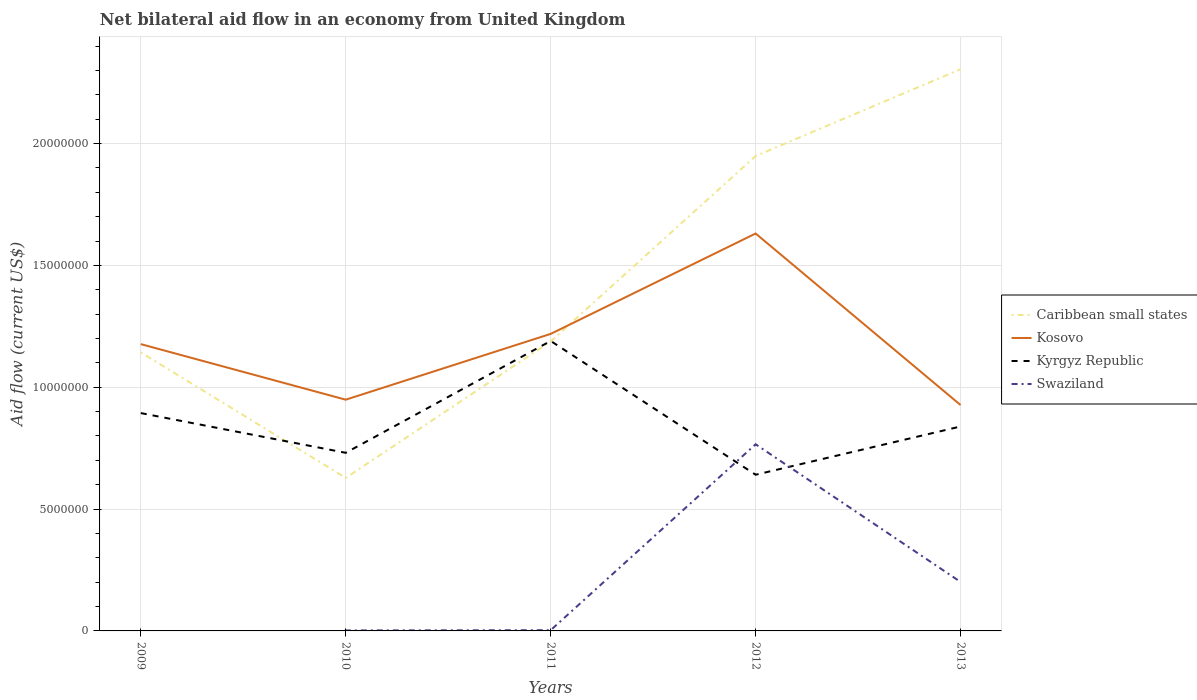Across all years, what is the maximum net bilateral aid flow in Caribbean small states?
Your response must be concise. 6.28e+06. What is the total net bilateral aid flow in Caribbean small states in the graph?
Keep it short and to the point. -4.50e+05. What is the difference between the highest and the second highest net bilateral aid flow in Kosovo?
Give a very brief answer. 7.04e+06. What is the difference between the highest and the lowest net bilateral aid flow in Kyrgyz Republic?
Ensure brevity in your answer.  2. How many years are there in the graph?
Provide a short and direct response. 5. What is the difference between two consecutive major ticks on the Y-axis?
Make the answer very short. 5.00e+06. How many legend labels are there?
Your response must be concise. 4. How are the legend labels stacked?
Provide a short and direct response. Vertical. What is the title of the graph?
Offer a terse response. Net bilateral aid flow in an economy from United Kingdom. What is the Aid flow (current US$) of Caribbean small states in 2009?
Make the answer very short. 1.14e+07. What is the Aid flow (current US$) in Kosovo in 2009?
Offer a terse response. 1.18e+07. What is the Aid flow (current US$) in Kyrgyz Republic in 2009?
Offer a terse response. 8.94e+06. What is the Aid flow (current US$) in Caribbean small states in 2010?
Provide a succinct answer. 6.28e+06. What is the Aid flow (current US$) in Kosovo in 2010?
Provide a short and direct response. 9.49e+06. What is the Aid flow (current US$) of Kyrgyz Republic in 2010?
Provide a short and direct response. 7.31e+06. What is the Aid flow (current US$) in Caribbean small states in 2011?
Your response must be concise. 1.19e+07. What is the Aid flow (current US$) of Kosovo in 2011?
Provide a succinct answer. 1.22e+07. What is the Aid flow (current US$) in Kyrgyz Republic in 2011?
Make the answer very short. 1.19e+07. What is the Aid flow (current US$) in Swaziland in 2011?
Make the answer very short. 3.00e+04. What is the Aid flow (current US$) in Caribbean small states in 2012?
Offer a very short reply. 1.95e+07. What is the Aid flow (current US$) in Kosovo in 2012?
Offer a very short reply. 1.63e+07. What is the Aid flow (current US$) in Kyrgyz Republic in 2012?
Offer a terse response. 6.41e+06. What is the Aid flow (current US$) of Swaziland in 2012?
Offer a terse response. 7.66e+06. What is the Aid flow (current US$) in Caribbean small states in 2013?
Provide a succinct answer. 2.30e+07. What is the Aid flow (current US$) in Kosovo in 2013?
Keep it short and to the point. 9.27e+06. What is the Aid flow (current US$) in Kyrgyz Republic in 2013?
Offer a terse response. 8.39e+06. What is the Aid flow (current US$) of Swaziland in 2013?
Your answer should be compact. 2.01e+06. Across all years, what is the maximum Aid flow (current US$) of Caribbean small states?
Ensure brevity in your answer.  2.30e+07. Across all years, what is the maximum Aid flow (current US$) in Kosovo?
Offer a very short reply. 1.63e+07. Across all years, what is the maximum Aid flow (current US$) in Kyrgyz Republic?
Keep it short and to the point. 1.19e+07. Across all years, what is the maximum Aid flow (current US$) in Swaziland?
Offer a terse response. 7.66e+06. Across all years, what is the minimum Aid flow (current US$) of Caribbean small states?
Ensure brevity in your answer.  6.28e+06. Across all years, what is the minimum Aid flow (current US$) of Kosovo?
Give a very brief answer. 9.27e+06. Across all years, what is the minimum Aid flow (current US$) of Kyrgyz Republic?
Ensure brevity in your answer.  6.41e+06. Across all years, what is the minimum Aid flow (current US$) in Swaziland?
Offer a terse response. 0. What is the total Aid flow (current US$) in Caribbean small states in the graph?
Your answer should be compact. 7.21e+07. What is the total Aid flow (current US$) of Kosovo in the graph?
Keep it short and to the point. 5.90e+07. What is the total Aid flow (current US$) of Kyrgyz Republic in the graph?
Provide a short and direct response. 4.30e+07. What is the total Aid flow (current US$) of Swaziland in the graph?
Ensure brevity in your answer.  9.72e+06. What is the difference between the Aid flow (current US$) of Caribbean small states in 2009 and that in 2010?
Offer a very short reply. 5.15e+06. What is the difference between the Aid flow (current US$) of Kosovo in 2009 and that in 2010?
Your answer should be compact. 2.28e+06. What is the difference between the Aid flow (current US$) of Kyrgyz Republic in 2009 and that in 2010?
Make the answer very short. 1.63e+06. What is the difference between the Aid flow (current US$) in Caribbean small states in 2009 and that in 2011?
Provide a succinct answer. -4.50e+05. What is the difference between the Aid flow (current US$) of Kosovo in 2009 and that in 2011?
Offer a very short reply. -4.20e+05. What is the difference between the Aid flow (current US$) of Kyrgyz Republic in 2009 and that in 2011?
Your answer should be compact. -2.96e+06. What is the difference between the Aid flow (current US$) of Caribbean small states in 2009 and that in 2012?
Ensure brevity in your answer.  -8.06e+06. What is the difference between the Aid flow (current US$) of Kosovo in 2009 and that in 2012?
Offer a terse response. -4.54e+06. What is the difference between the Aid flow (current US$) of Kyrgyz Republic in 2009 and that in 2012?
Your answer should be compact. 2.53e+06. What is the difference between the Aid flow (current US$) in Caribbean small states in 2009 and that in 2013?
Ensure brevity in your answer.  -1.16e+07. What is the difference between the Aid flow (current US$) of Kosovo in 2009 and that in 2013?
Make the answer very short. 2.50e+06. What is the difference between the Aid flow (current US$) of Caribbean small states in 2010 and that in 2011?
Offer a terse response. -5.60e+06. What is the difference between the Aid flow (current US$) of Kosovo in 2010 and that in 2011?
Your response must be concise. -2.70e+06. What is the difference between the Aid flow (current US$) in Kyrgyz Republic in 2010 and that in 2011?
Ensure brevity in your answer.  -4.59e+06. What is the difference between the Aid flow (current US$) of Swaziland in 2010 and that in 2011?
Make the answer very short. -10000. What is the difference between the Aid flow (current US$) in Caribbean small states in 2010 and that in 2012?
Keep it short and to the point. -1.32e+07. What is the difference between the Aid flow (current US$) of Kosovo in 2010 and that in 2012?
Make the answer very short. -6.82e+06. What is the difference between the Aid flow (current US$) in Kyrgyz Republic in 2010 and that in 2012?
Your answer should be very brief. 9.00e+05. What is the difference between the Aid flow (current US$) of Swaziland in 2010 and that in 2012?
Provide a succinct answer. -7.64e+06. What is the difference between the Aid flow (current US$) in Caribbean small states in 2010 and that in 2013?
Ensure brevity in your answer.  -1.68e+07. What is the difference between the Aid flow (current US$) in Kyrgyz Republic in 2010 and that in 2013?
Your answer should be very brief. -1.08e+06. What is the difference between the Aid flow (current US$) in Swaziland in 2010 and that in 2013?
Your answer should be very brief. -1.99e+06. What is the difference between the Aid flow (current US$) in Caribbean small states in 2011 and that in 2012?
Your answer should be compact. -7.61e+06. What is the difference between the Aid flow (current US$) of Kosovo in 2011 and that in 2012?
Your answer should be very brief. -4.12e+06. What is the difference between the Aid flow (current US$) in Kyrgyz Republic in 2011 and that in 2012?
Ensure brevity in your answer.  5.49e+06. What is the difference between the Aid flow (current US$) in Swaziland in 2011 and that in 2012?
Offer a very short reply. -7.63e+06. What is the difference between the Aid flow (current US$) in Caribbean small states in 2011 and that in 2013?
Your response must be concise. -1.12e+07. What is the difference between the Aid flow (current US$) in Kosovo in 2011 and that in 2013?
Provide a short and direct response. 2.92e+06. What is the difference between the Aid flow (current US$) in Kyrgyz Republic in 2011 and that in 2013?
Your response must be concise. 3.51e+06. What is the difference between the Aid flow (current US$) in Swaziland in 2011 and that in 2013?
Your response must be concise. -1.98e+06. What is the difference between the Aid flow (current US$) in Caribbean small states in 2012 and that in 2013?
Give a very brief answer. -3.56e+06. What is the difference between the Aid flow (current US$) of Kosovo in 2012 and that in 2013?
Make the answer very short. 7.04e+06. What is the difference between the Aid flow (current US$) in Kyrgyz Republic in 2012 and that in 2013?
Offer a terse response. -1.98e+06. What is the difference between the Aid flow (current US$) in Swaziland in 2012 and that in 2013?
Give a very brief answer. 5.65e+06. What is the difference between the Aid flow (current US$) in Caribbean small states in 2009 and the Aid flow (current US$) in Kosovo in 2010?
Offer a very short reply. 1.94e+06. What is the difference between the Aid flow (current US$) in Caribbean small states in 2009 and the Aid flow (current US$) in Kyrgyz Republic in 2010?
Provide a succinct answer. 4.12e+06. What is the difference between the Aid flow (current US$) of Caribbean small states in 2009 and the Aid flow (current US$) of Swaziland in 2010?
Offer a terse response. 1.14e+07. What is the difference between the Aid flow (current US$) in Kosovo in 2009 and the Aid flow (current US$) in Kyrgyz Republic in 2010?
Offer a very short reply. 4.46e+06. What is the difference between the Aid flow (current US$) in Kosovo in 2009 and the Aid flow (current US$) in Swaziland in 2010?
Offer a terse response. 1.18e+07. What is the difference between the Aid flow (current US$) of Kyrgyz Republic in 2009 and the Aid flow (current US$) of Swaziland in 2010?
Keep it short and to the point. 8.92e+06. What is the difference between the Aid flow (current US$) in Caribbean small states in 2009 and the Aid flow (current US$) in Kosovo in 2011?
Offer a terse response. -7.60e+05. What is the difference between the Aid flow (current US$) of Caribbean small states in 2009 and the Aid flow (current US$) of Kyrgyz Republic in 2011?
Provide a short and direct response. -4.70e+05. What is the difference between the Aid flow (current US$) of Caribbean small states in 2009 and the Aid flow (current US$) of Swaziland in 2011?
Your answer should be compact. 1.14e+07. What is the difference between the Aid flow (current US$) of Kosovo in 2009 and the Aid flow (current US$) of Swaziland in 2011?
Provide a succinct answer. 1.17e+07. What is the difference between the Aid flow (current US$) of Kyrgyz Republic in 2009 and the Aid flow (current US$) of Swaziland in 2011?
Your response must be concise. 8.91e+06. What is the difference between the Aid flow (current US$) in Caribbean small states in 2009 and the Aid flow (current US$) in Kosovo in 2012?
Provide a succinct answer. -4.88e+06. What is the difference between the Aid flow (current US$) of Caribbean small states in 2009 and the Aid flow (current US$) of Kyrgyz Republic in 2012?
Provide a succinct answer. 5.02e+06. What is the difference between the Aid flow (current US$) of Caribbean small states in 2009 and the Aid flow (current US$) of Swaziland in 2012?
Make the answer very short. 3.77e+06. What is the difference between the Aid flow (current US$) in Kosovo in 2009 and the Aid flow (current US$) in Kyrgyz Republic in 2012?
Your answer should be compact. 5.36e+06. What is the difference between the Aid flow (current US$) in Kosovo in 2009 and the Aid flow (current US$) in Swaziland in 2012?
Offer a terse response. 4.11e+06. What is the difference between the Aid flow (current US$) of Kyrgyz Republic in 2009 and the Aid flow (current US$) of Swaziland in 2012?
Give a very brief answer. 1.28e+06. What is the difference between the Aid flow (current US$) in Caribbean small states in 2009 and the Aid flow (current US$) in Kosovo in 2013?
Your answer should be very brief. 2.16e+06. What is the difference between the Aid flow (current US$) of Caribbean small states in 2009 and the Aid flow (current US$) of Kyrgyz Republic in 2013?
Provide a succinct answer. 3.04e+06. What is the difference between the Aid flow (current US$) of Caribbean small states in 2009 and the Aid flow (current US$) of Swaziland in 2013?
Keep it short and to the point. 9.42e+06. What is the difference between the Aid flow (current US$) of Kosovo in 2009 and the Aid flow (current US$) of Kyrgyz Republic in 2013?
Ensure brevity in your answer.  3.38e+06. What is the difference between the Aid flow (current US$) of Kosovo in 2009 and the Aid flow (current US$) of Swaziland in 2013?
Provide a succinct answer. 9.76e+06. What is the difference between the Aid flow (current US$) of Kyrgyz Republic in 2009 and the Aid flow (current US$) of Swaziland in 2013?
Keep it short and to the point. 6.93e+06. What is the difference between the Aid flow (current US$) in Caribbean small states in 2010 and the Aid flow (current US$) in Kosovo in 2011?
Keep it short and to the point. -5.91e+06. What is the difference between the Aid flow (current US$) of Caribbean small states in 2010 and the Aid flow (current US$) of Kyrgyz Republic in 2011?
Make the answer very short. -5.62e+06. What is the difference between the Aid flow (current US$) in Caribbean small states in 2010 and the Aid flow (current US$) in Swaziland in 2011?
Your answer should be very brief. 6.25e+06. What is the difference between the Aid flow (current US$) in Kosovo in 2010 and the Aid flow (current US$) in Kyrgyz Republic in 2011?
Your response must be concise. -2.41e+06. What is the difference between the Aid flow (current US$) of Kosovo in 2010 and the Aid flow (current US$) of Swaziland in 2011?
Your answer should be compact. 9.46e+06. What is the difference between the Aid flow (current US$) of Kyrgyz Republic in 2010 and the Aid flow (current US$) of Swaziland in 2011?
Make the answer very short. 7.28e+06. What is the difference between the Aid flow (current US$) of Caribbean small states in 2010 and the Aid flow (current US$) of Kosovo in 2012?
Ensure brevity in your answer.  -1.00e+07. What is the difference between the Aid flow (current US$) in Caribbean small states in 2010 and the Aid flow (current US$) in Swaziland in 2012?
Offer a terse response. -1.38e+06. What is the difference between the Aid flow (current US$) in Kosovo in 2010 and the Aid flow (current US$) in Kyrgyz Republic in 2012?
Make the answer very short. 3.08e+06. What is the difference between the Aid flow (current US$) of Kosovo in 2010 and the Aid flow (current US$) of Swaziland in 2012?
Make the answer very short. 1.83e+06. What is the difference between the Aid flow (current US$) of Kyrgyz Republic in 2010 and the Aid flow (current US$) of Swaziland in 2012?
Give a very brief answer. -3.50e+05. What is the difference between the Aid flow (current US$) of Caribbean small states in 2010 and the Aid flow (current US$) of Kosovo in 2013?
Offer a terse response. -2.99e+06. What is the difference between the Aid flow (current US$) in Caribbean small states in 2010 and the Aid flow (current US$) in Kyrgyz Republic in 2013?
Your answer should be very brief. -2.11e+06. What is the difference between the Aid flow (current US$) in Caribbean small states in 2010 and the Aid flow (current US$) in Swaziland in 2013?
Provide a short and direct response. 4.27e+06. What is the difference between the Aid flow (current US$) of Kosovo in 2010 and the Aid flow (current US$) of Kyrgyz Republic in 2013?
Your response must be concise. 1.10e+06. What is the difference between the Aid flow (current US$) in Kosovo in 2010 and the Aid flow (current US$) in Swaziland in 2013?
Your response must be concise. 7.48e+06. What is the difference between the Aid flow (current US$) in Kyrgyz Republic in 2010 and the Aid flow (current US$) in Swaziland in 2013?
Keep it short and to the point. 5.30e+06. What is the difference between the Aid flow (current US$) in Caribbean small states in 2011 and the Aid flow (current US$) in Kosovo in 2012?
Offer a very short reply. -4.43e+06. What is the difference between the Aid flow (current US$) in Caribbean small states in 2011 and the Aid flow (current US$) in Kyrgyz Republic in 2012?
Your answer should be compact. 5.47e+06. What is the difference between the Aid flow (current US$) in Caribbean small states in 2011 and the Aid flow (current US$) in Swaziland in 2012?
Your response must be concise. 4.22e+06. What is the difference between the Aid flow (current US$) of Kosovo in 2011 and the Aid flow (current US$) of Kyrgyz Republic in 2012?
Your answer should be compact. 5.78e+06. What is the difference between the Aid flow (current US$) in Kosovo in 2011 and the Aid flow (current US$) in Swaziland in 2012?
Your answer should be compact. 4.53e+06. What is the difference between the Aid flow (current US$) in Kyrgyz Republic in 2011 and the Aid flow (current US$) in Swaziland in 2012?
Your answer should be compact. 4.24e+06. What is the difference between the Aid flow (current US$) of Caribbean small states in 2011 and the Aid flow (current US$) of Kosovo in 2013?
Your answer should be compact. 2.61e+06. What is the difference between the Aid flow (current US$) of Caribbean small states in 2011 and the Aid flow (current US$) of Kyrgyz Republic in 2013?
Give a very brief answer. 3.49e+06. What is the difference between the Aid flow (current US$) of Caribbean small states in 2011 and the Aid flow (current US$) of Swaziland in 2013?
Your answer should be very brief. 9.87e+06. What is the difference between the Aid flow (current US$) of Kosovo in 2011 and the Aid flow (current US$) of Kyrgyz Republic in 2013?
Offer a very short reply. 3.80e+06. What is the difference between the Aid flow (current US$) in Kosovo in 2011 and the Aid flow (current US$) in Swaziland in 2013?
Provide a short and direct response. 1.02e+07. What is the difference between the Aid flow (current US$) in Kyrgyz Republic in 2011 and the Aid flow (current US$) in Swaziland in 2013?
Offer a terse response. 9.89e+06. What is the difference between the Aid flow (current US$) of Caribbean small states in 2012 and the Aid flow (current US$) of Kosovo in 2013?
Your answer should be compact. 1.02e+07. What is the difference between the Aid flow (current US$) in Caribbean small states in 2012 and the Aid flow (current US$) in Kyrgyz Republic in 2013?
Provide a short and direct response. 1.11e+07. What is the difference between the Aid flow (current US$) in Caribbean small states in 2012 and the Aid flow (current US$) in Swaziland in 2013?
Keep it short and to the point. 1.75e+07. What is the difference between the Aid flow (current US$) of Kosovo in 2012 and the Aid flow (current US$) of Kyrgyz Republic in 2013?
Your response must be concise. 7.92e+06. What is the difference between the Aid flow (current US$) in Kosovo in 2012 and the Aid flow (current US$) in Swaziland in 2013?
Ensure brevity in your answer.  1.43e+07. What is the difference between the Aid flow (current US$) of Kyrgyz Republic in 2012 and the Aid flow (current US$) of Swaziland in 2013?
Offer a terse response. 4.40e+06. What is the average Aid flow (current US$) in Caribbean small states per year?
Keep it short and to the point. 1.44e+07. What is the average Aid flow (current US$) of Kosovo per year?
Provide a succinct answer. 1.18e+07. What is the average Aid flow (current US$) in Kyrgyz Republic per year?
Give a very brief answer. 8.59e+06. What is the average Aid flow (current US$) of Swaziland per year?
Offer a very short reply. 1.94e+06. In the year 2009, what is the difference between the Aid flow (current US$) in Caribbean small states and Aid flow (current US$) in Kosovo?
Make the answer very short. -3.40e+05. In the year 2009, what is the difference between the Aid flow (current US$) of Caribbean small states and Aid flow (current US$) of Kyrgyz Republic?
Your response must be concise. 2.49e+06. In the year 2009, what is the difference between the Aid flow (current US$) in Kosovo and Aid flow (current US$) in Kyrgyz Republic?
Your answer should be very brief. 2.83e+06. In the year 2010, what is the difference between the Aid flow (current US$) of Caribbean small states and Aid flow (current US$) of Kosovo?
Your response must be concise. -3.21e+06. In the year 2010, what is the difference between the Aid flow (current US$) in Caribbean small states and Aid flow (current US$) in Kyrgyz Republic?
Make the answer very short. -1.03e+06. In the year 2010, what is the difference between the Aid flow (current US$) in Caribbean small states and Aid flow (current US$) in Swaziland?
Keep it short and to the point. 6.26e+06. In the year 2010, what is the difference between the Aid flow (current US$) of Kosovo and Aid flow (current US$) of Kyrgyz Republic?
Give a very brief answer. 2.18e+06. In the year 2010, what is the difference between the Aid flow (current US$) of Kosovo and Aid flow (current US$) of Swaziland?
Your answer should be compact. 9.47e+06. In the year 2010, what is the difference between the Aid flow (current US$) in Kyrgyz Republic and Aid flow (current US$) in Swaziland?
Provide a succinct answer. 7.29e+06. In the year 2011, what is the difference between the Aid flow (current US$) in Caribbean small states and Aid flow (current US$) in Kosovo?
Offer a terse response. -3.10e+05. In the year 2011, what is the difference between the Aid flow (current US$) of Caribbean small states and Aid flow (current US$) of Kyrgyz Republic?
Offer a terse response. -2.00e+04. In the year 2011, what is the difference between the Aid flow (current US$) in Caribbean small states and Aid flow (current US$) in Swaziland?
Provide a short and direct response. 1.18e+07. In the year 2011, what is the difference between the Aid flow (current US$) in Kosovo and Aid flow (current US$) in Kyrgyz Republic?
Ensure brevity in your answer.  2.90e+05. In the year 2011, what is the difference between the Aid flow (current US$) of Kosovo and Aid flow (current US$) of Swaziland?
Your answer should be very brief. 1.22e+07. In the year 2011, what is the difference between the Aid flow (current US$) in Kyrgyz Republic and Aid flow (current US$) in Swaziland?
Keep it short and to the point. 1.19e+07. In the year 2012, what is the difference between the Aid flow (current US$) of Caribbean small states and Aid flow (current US$) of Kosovo?
Give a very brief answer. 3.18e+06. In the year 2012, what is the difference between the Aid flow (current US$) of Caribbean small states and Aid flow (current US$) of Kyrgyz Republic?
Offer a very short reply. 1.31e+07. In the year 2012, what is the difference between the Aid flow (current US$) of Caribbean small states and Aid flow (current US$) of Swaziland?
Give a very brief answer. 1.18e+07. In the year 2012, what is the difference between the Aid flow (current US$) of Kosovo and Aid flow (current US$) of Kyrgyz Republic?
Provide a short and direct response. 9.90e+06. In the year 2012, what is the difference between the Aid flow (current US$) of Kosovo and Aid flow (current US$) of Swaziland?
Your answer should be very brief. 8.65e+06. In the year 2012, what is the difference between the Aid flow (current US$) in Kyrgyz Republic and Aid flow (current US$) in Swaziland?
Your answer should be compact. -1.25e+06. In the year 2013, what is the difference between the Aid flow (current US$) in Caribbean small states and Aid flow (current US$) in Kosovo?
Provide a succinct answer. 1.38e+07. In the year 2013, what is the difference between the Aid flow (current US$) of Caribbean small states and Aid flow (current US$) of Kyrgyz Republic?
Your answer should be compact. 1.47e+07. In the year 2013, what is the difference between the Aid flow (current US$) of Caribbean small states and Aid flow (current US$) of Swaziland?
Provide a short and direct response. 2.10e+07. In the year 2013, what is the difference between the Aid flow (current US$) of Kosovo and Aid flow (current US$) of Kyrgyz Republic?
Provide a succinct answer. 8.80e+05. In the year 2013, what is the difference between the Aid flow (current US$) of Kosovo and Aid flow (current US$) of Swaziland?
Offer a very short reply. 7.26e+06. In the year 2013, what is the difference between the Aid flow (current US$) of Kyrgyz Republic and Aid flow (current US$) of Swaziland?
Offer a terse response. 6.38e+06. What is the ratio of the Aid flow (current US$) of Caribbean small states in 2009 to that in 2010?
Ensure brevity in your answer.  1.82. What is the ratio of the Aid flow (current US$) of Kosovo in 2009 to that in 2010?
Offer a terse response. 1.24. What is the ratio of the Aid flow (current US$) of Kyrgyz Republic in 2009 to that in 2010?
Give a very brief answer. 1.22. What is the ratio of the Aid flow (current US$) in Caribbean small states in 2009 to that in 2011?
Your response must be concise. 0.96. What is the ratio of the Aid flow (current US$) in Kosovo in 2009 to that in 2011?
Make the answer very short. 0.97. What is the ratio of the Aid flow (current US$) of Kyrgyz Republic in 2009 to that in 2011?
Make the answer very short. 0.75. What is the ratio of the Aid flow (current US$) of Caribbean small states in 2009 to that in 2012?
Your answer should be very brief. 0.59. What is the ratio of the Aid flow (current US$) of Kosovo in 2009 to that in 2012?
Provide a succinct answer. 0.72. What is the ratio of the Aid flow (current US$) of Kyrgyz Republic in 2009 to that in 2012?
Give a very brief answer. 1.39. What is the ratio of the Aid flow (current US$) in Caribbean small states in 2009 to that in 2013?
Your response must be concise. 0.5. What is the ratio of the Aid flow (current US$) of Kosovo in 2009 to that in 2013?
Offer a very short reply. 1.27. What is the ratio of the Aid flow (current US$) in Kyrgyz Republic in 2009 to that in 2013?
Your answer should be compact. 1.07. What is the ratio of the Aid flow (current US$) in Caribbean small states in 2010 to that in 2011?
Your answer should be compact. 0.53. What is the ratio of the Aid flow (current US$) of Kosovo in 2010 to that in 2011?
Provide a short and direct response. 0.78. What is the ratio of the Aid flow (current US$) of Kyrgyz Republic in 2010 to that in 2011?
Your answer should be compact. 0.61. What is the ratio of the Aid flow (current US$) of Swaziland in 2010 to that in 2011?
Make the answer very short. 0.67. What is the ratio of the Aid flow (current US$) of Caribbean small states in 2010 to that in 2012?
Your response must be concise. 0.32. What is the ratio of the Aid flow (current US$) in Kosovo in 2010 to that in 2012?
Your answer should be very brief. 0.58. What is the ratio of the Aid flow (current US$) of Kyrgyz Republic in 2010 to that in 2012?
Ensure brevity in your answer.  1.14. What is the ratio of the Aid flow (current US$) in Swaziland in 2010 to that in 2012?
Ensure brevity in your answer.  0. What is the ratio of the Aid flow (current US$) of Caribbean small states in 2010 to that in 2013?
Keep it short and to the point. 0.27. What is the ratio of the Aid flow (current US$) of Kosovo in 2010 to that in 2013?
Give a very brief answer. 1.02. What is the ratio of the Aid flow (current US$) of Kyrgyz Republic in 2010 to that in 2013?
Your answer should be very brief. 0.87. What is the ratio of the Aid flow (current US$) of Caribbean small states in 2011 to that in 2012?
Give a very brief answer. 0.61. What is the ratio of the Aid flow (current US$) in Kosovo in 2011 to that in 2012?
Make the answer very short. 0.75. What is the ratio of the Aid flow (current US$) of Kyrgyz Republic in 2011 to that in 2012?
Your response must be concise. 1.86. What is the ratio of the Aid flow (current US$) of Swaziland in 2011 to that in 2012?
Your response must be concise. 0. What is the ratio of the Aid flow (current US$) of Caribbean small states in 2011 to that in 2013?
Offer a very short reply. 0.52. What is the ratio of the Aid flow (current US$) in Kosovo in 2011 to that in 2013?
Your response must be concise. 1.31. What is the ratio of the Aid flow (current US$) in Kyrgyz Republic in 2011 to that in 2013?
Your answer should be compact. 1.42. What is the ratio of the Aid flow (current US$) of Swaziland in 2011 to that in 2013?
Make the answer very short. 0.01. What is the ratio of the Aid flow (current US$) of Caribbean small states in 2012 to that in 2013?
Your answer should be compact. 0.85. What is the ratio of the Aid flow (current US$) of Kosovo in 2012 to that in 2013?
Offer a very short reply. 1.76. What is the ratio of the Aid flow (current US$) of Kyrgyz Republic in 2012 to that in 2013?
Your answer should be very brief. 0.76. What is the ratio of the Aid flow (current US$) in Swaziland in 2012 to that in 2013?
Provide a succinct answer. 3.81. What is the difference between the highest and the second highest Aid flow (current US$) in Caribbean small states?
Give a very brief answer. 3.56e+06. What is the difference between the highest and the second highest Aid flow (current US$) of Kosovo?
Your answer should be compact. 4.12e+06. What is the difference between the highest and the second highest Aid flow (current US$) in Kyrgyz Republic?
Make the answer very short. 2.96e+06. What is the difference between the highest and the second highest Aid flow (current US$) of Swaziland?
Provide a short and direct response. 5.65e+06. What is the difference between the highest and the lowest Aid flow (current US$) of Caribbean small states?
Your answer should be compact. 1.68e+07. What is the difference between the highest and the lowest Aid flow (current US$) of Kosovo?
Your response must be concise. 7.04e+06. What is the difference between the highest and the lowest Aid flow (current US$) in Kyrgyz Republic?
Provide a succinct answer. 5.49e+06. What is the difference between the highest and the lowest Aid flow (current US$) in Swaziland?
Offer a terse response. 7.66e+06. 